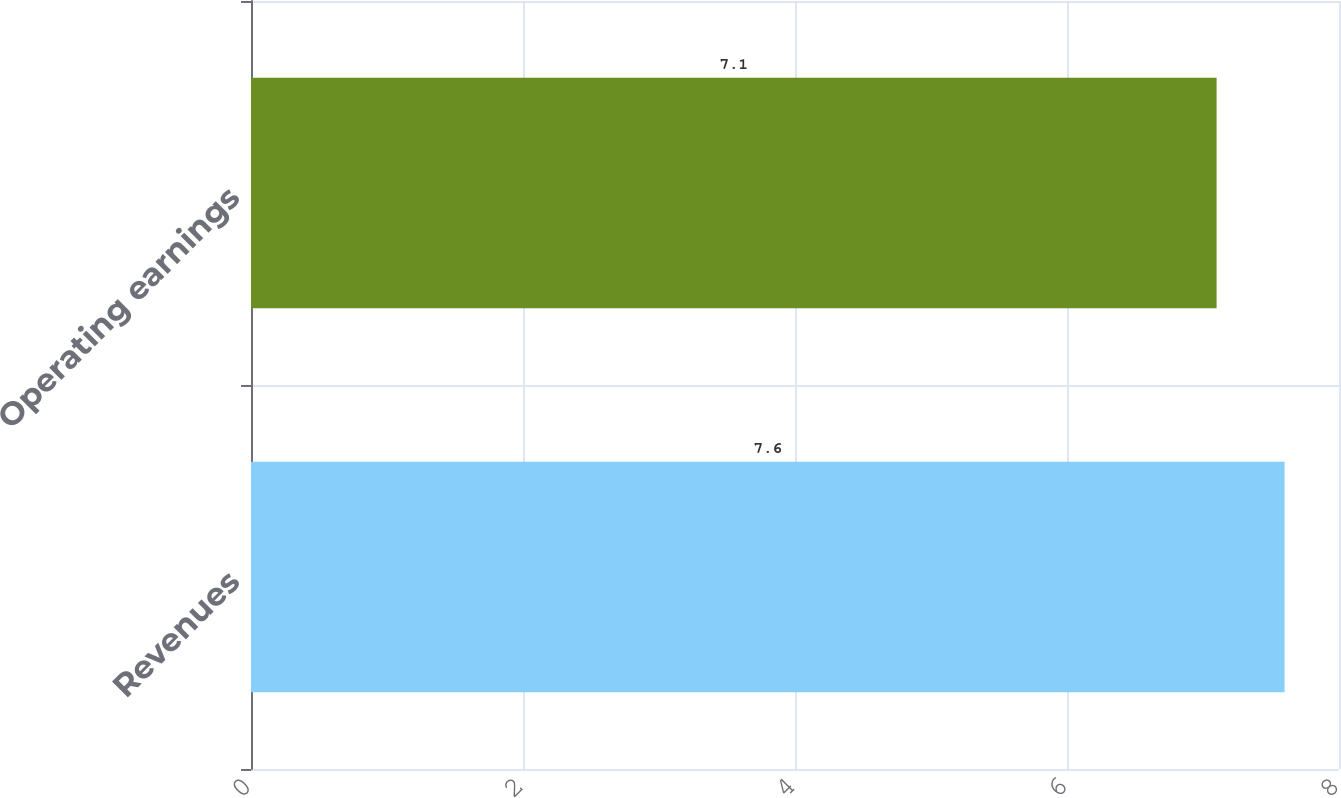Convert chart to OTSL. <chart><loc_0><loc_0><loc_500><loc_500><bar_chart><fcel>Revenues<fcel>Operating earnings<nl><fcel>7.6<fcel>7.1<nl></chart> 